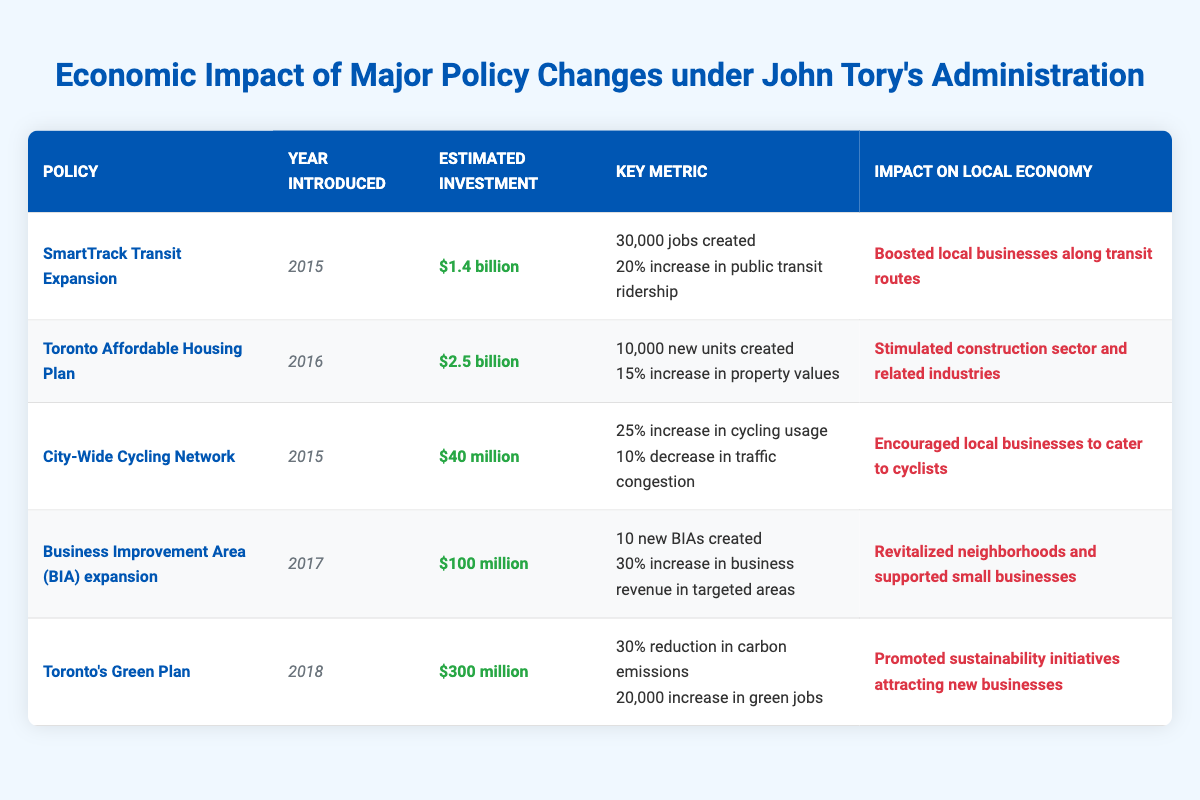What year was the SmartTrack Transit Expansion introduced? The year is listed in the second column under the SmartTrack Transit Expansion policy. It shows 2015.
Answer: 2015 How many new units were created under the Toronto Affordable Housing Plan? The table specifies in the fourth column that 10,000 new units were created under this policy.
Answer: 10,000 Which policy had the highest estimated investment? By comparing the estimated investment amounts in the third column, Toronto Affordable Housing Plan with $2.5 billion has the highest investment.
Answer: Toronto Affordable Housing Plan What was the total estimated investment for the SmartTrack Transit Expansion and the City-Wide Cycling Network combined? The estimated investments for SmartTrack Transit Expansion ($1.4 billion) and City-Wide Cycling Network ($40 million) are summed up: $1.4 billion + $0.04 billion = $1.44 billion.
Answer: $1.44 billion Did the Business Improvement Area (BIA) expansion lead to an increase in business revenue? The table confirms in the fifth column that there was a 30% increase in business revenue in targeted areas with the BIA expansion policy.
Answer: Yes How many jobs were created through the Toronto's Green Plan? The third column shows that 20,000 green jobs were created under Toronto's Green Plan.
Answer: 20,000 Which two policies from the table were introduced in 2015? Referring to the second column, both SmartTrack Transit Expansion and City-Wide Cycling Network were introduced in 2015.
Answer: SmartTrack Transit Expansion and City-Wide Cycling Network What is the difference in estimated investment between the Toronto Affordable Housing Plan and the Business Improvement Area (BIA) expansion? The estimated investment for Toronto Affordable Housing Plan is $2.5 billion and for BIA expansion is $100 million. Converting to the same units gives: $2.5 billion - $0.1 billion = $2.4 billion.
Answer: $2.4 billion How much did the City-Wide Cycling Network decrease traffic congestion? According to the table, City-Wide Cycling Network led to a 10% decrease in traffic congestion, stated in the relevant column.
Answer: 10% Based on the policies listed, which policy has the largest impact on local businesses, and what was that impact? The policy with the largest impact appears to be Business Improvement Area (BIA) expansion, with an impact described as revitalize neighborhoods and support small businesses.
Answer: Business Improvement Area (BIA) expansion; Revitalized neighborhoods and supported small businesses 